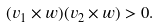Convert formula to latex. <formula><loc_0><loc_0><loc_500><loc_500>( v _ { 1 } \times w ) ( v _ { 2 } \times w ) > 0 .</formula> 